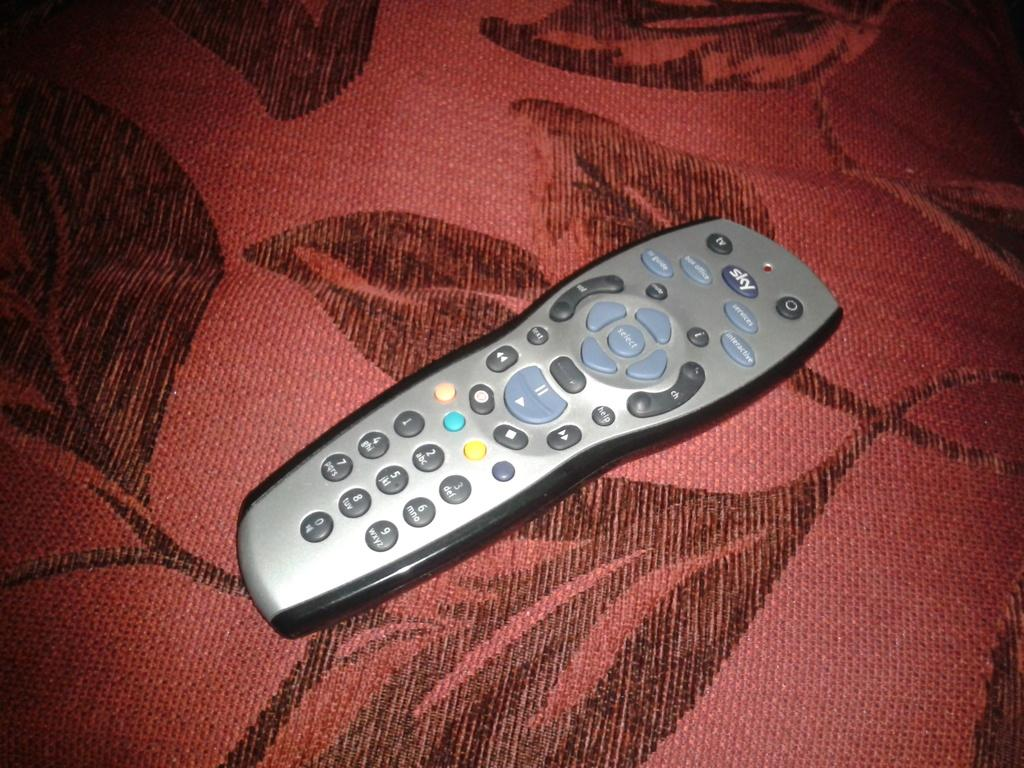<image>
Describe the image concisely. The sky remote control sits on a red couch with a black leaf pattern. 